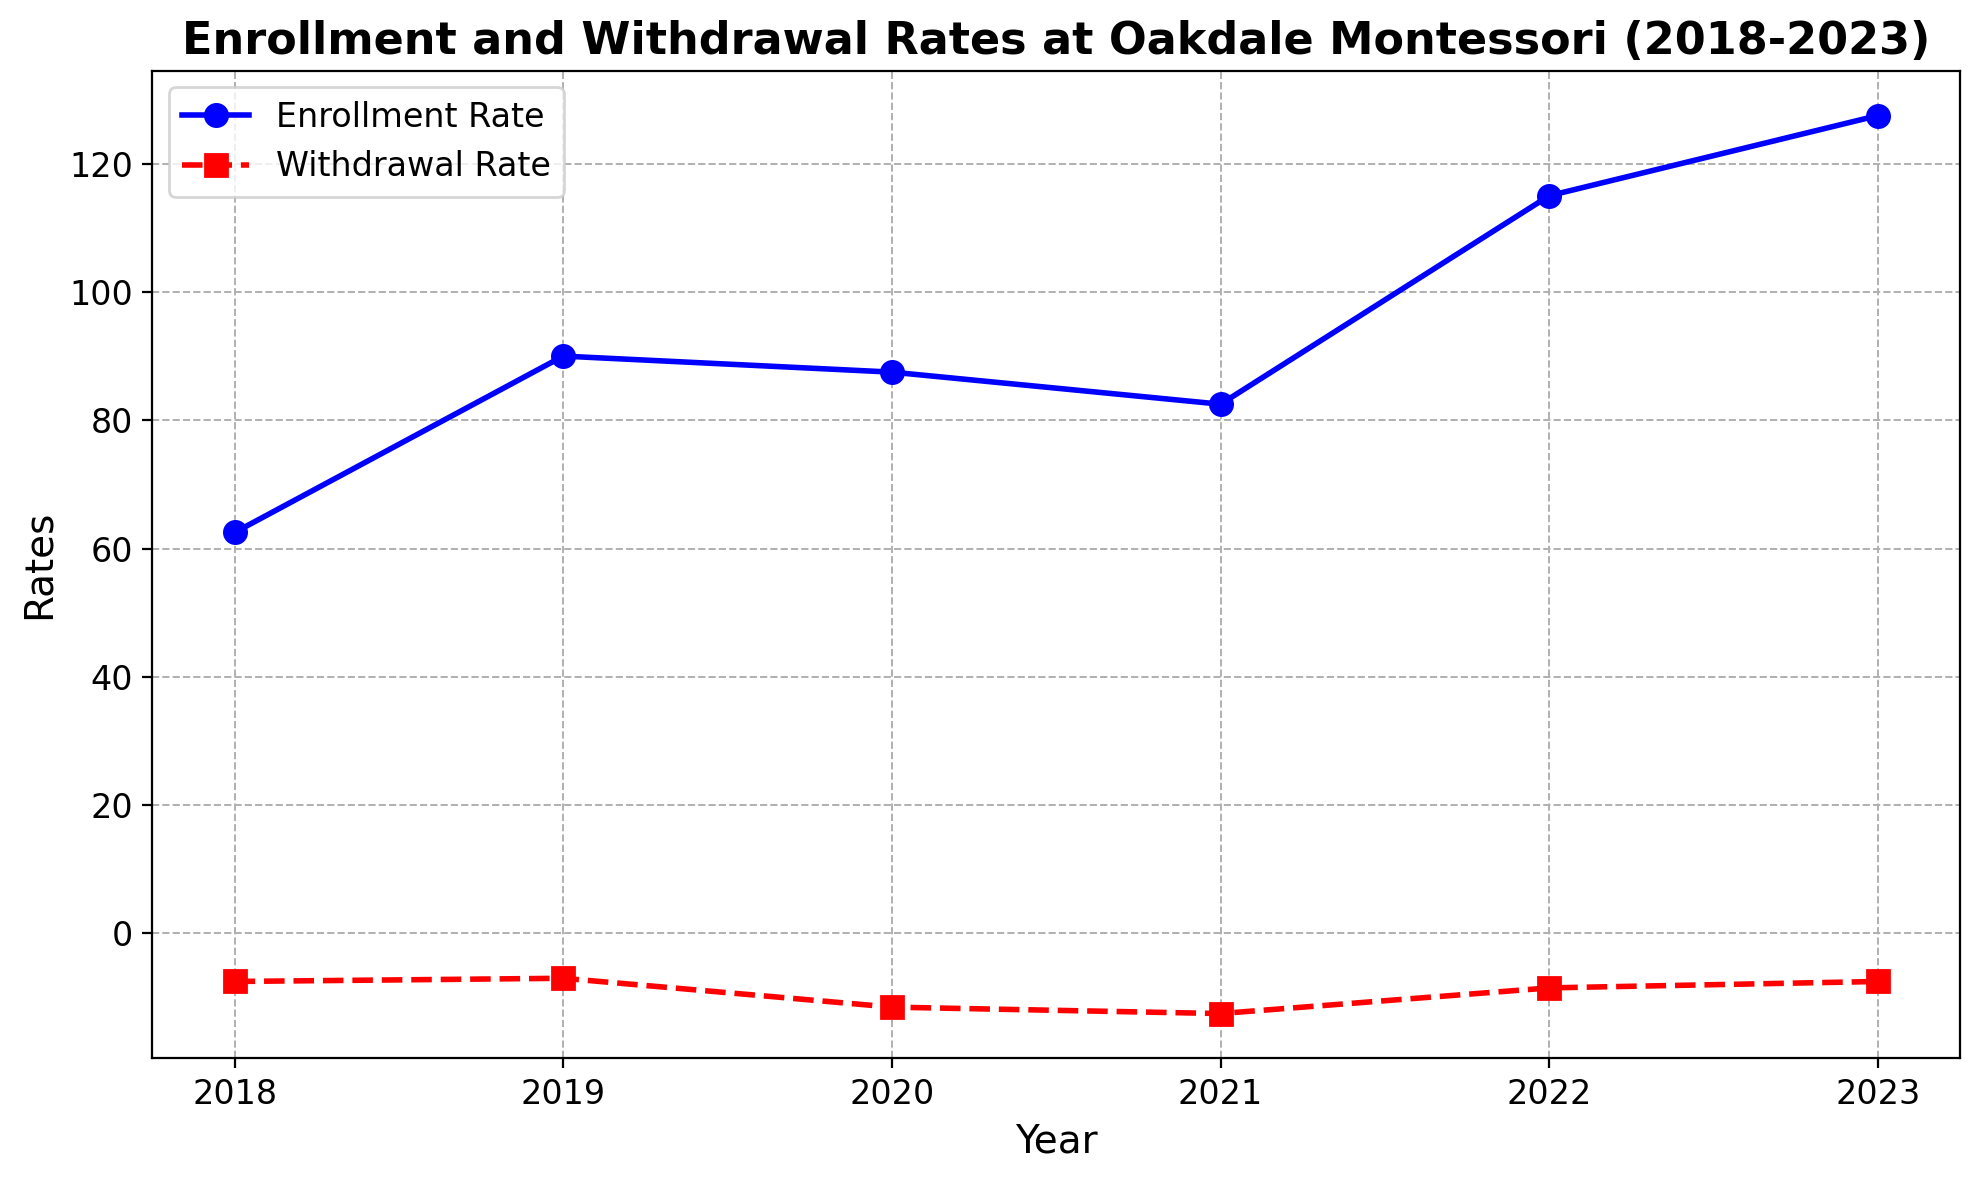Which year had the highest enrollment rate? The enrollment rates are plotted as blue lines with circular markers. The highest value on the enrollment rate line occurs in 2023.
Answer: 2023 How did the withdrawal rate change from 2020 to 2021? The withdrawal rate is plotted as red lines with square markers. In 2020, the withdrawal rate was -11.5 on average, and in 2021, it dropped to -12.5, indicating an increase in withdrawal rate.
Answer: Increased In which year was the difference between enrollment rate and withdrawal rate the smallest? We need to find the year where the absolute difference between enrollment rate and withdrawal rate is smallest. In 2020, the enrollment rate was closest to the withdrawal rate as the average enrollment rate was 87.5 and withdrawal rate was -11.5 yielding an absolute difference of 99.
Answer: 2020 What is the general trend in enrollment rate from 2018 to 2023? By observing the blue line for enrollment rates, we see that the general trend is an increase from 50 in 2018 to 130 in 2023.
Answer: Increasing Compare the withdrawal rates in 2018 and 2022. Which one is higher? The withdrawal rate for 2018 has two data points, -7.5 on average, and for 2022, the withdrawal rate is -8.5 on average. Since -7.5 is higher (less negative) than -8.5, the withdrawal rate in 2018 is higher.
Answer: 2018 Was there any year where the withdrawal rate was consistent across both records? By looking at the red markers on the line chart, in 2021, the withdrawal rate is consistently -12.5 across both records.
Answer: 2021 What is the average enrollment rate for 2020 and 2021 combined? The enrollment rates for 2020 are 87.5 and for 2021 are 82.5, so the average is (87.5+82.5)/2 = 85.
Answer: 85 Which year shows the steepest increase in enrollment rate? By evaluating the slope of the blue line, the steepest increase in enrollment rate occurs from 2021 (82.5) to 2022 (115). The steepest rise is 32.5.
Answer: 2021-2022 What is the difference between the highest enrollment rate and the lowest withdrawal rate? The highest enrollment rate is 125 in 2023, and the lowest withdrawal rate is -12.5 in 2021. The difference is 125 - (-20) = 145.
Answer: 140 